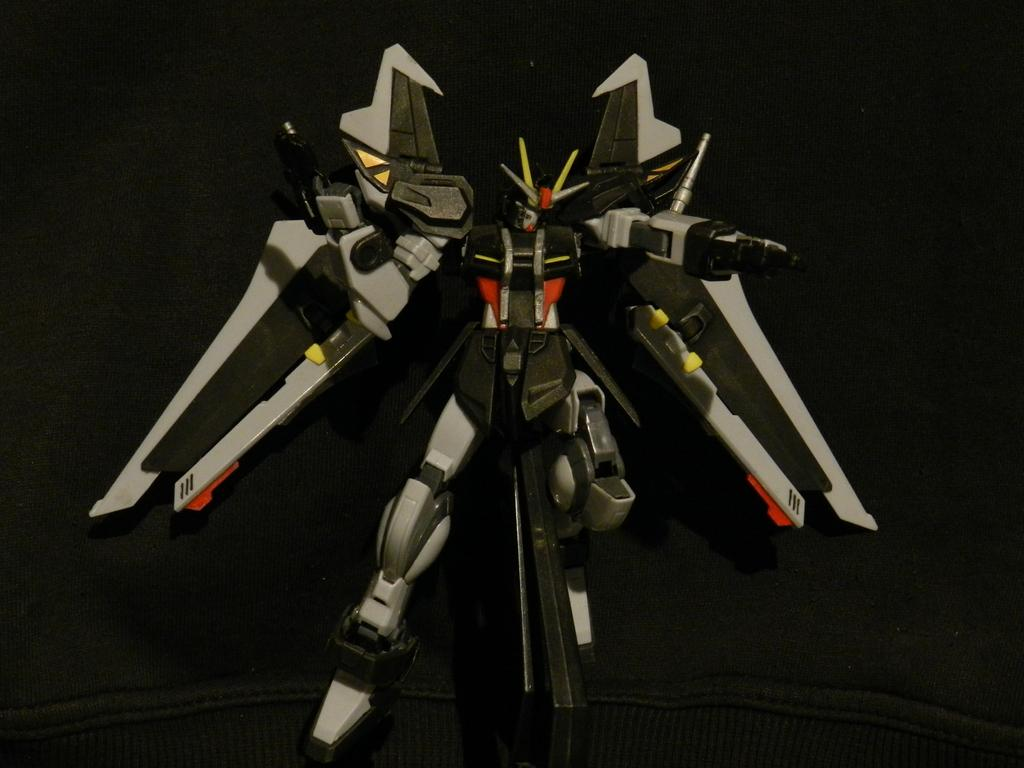What is the main subject of the image? There is a robot in the image. What can be observed about the background of the image? The background of the image is dark. Is the robot driving a car in the image? There is no car or indication of driving in the image; it only features a robot. What type of surprise can be seen in the image? There is no surprise or any indication of a surprise in the image; it only features a robot and a dark background. 